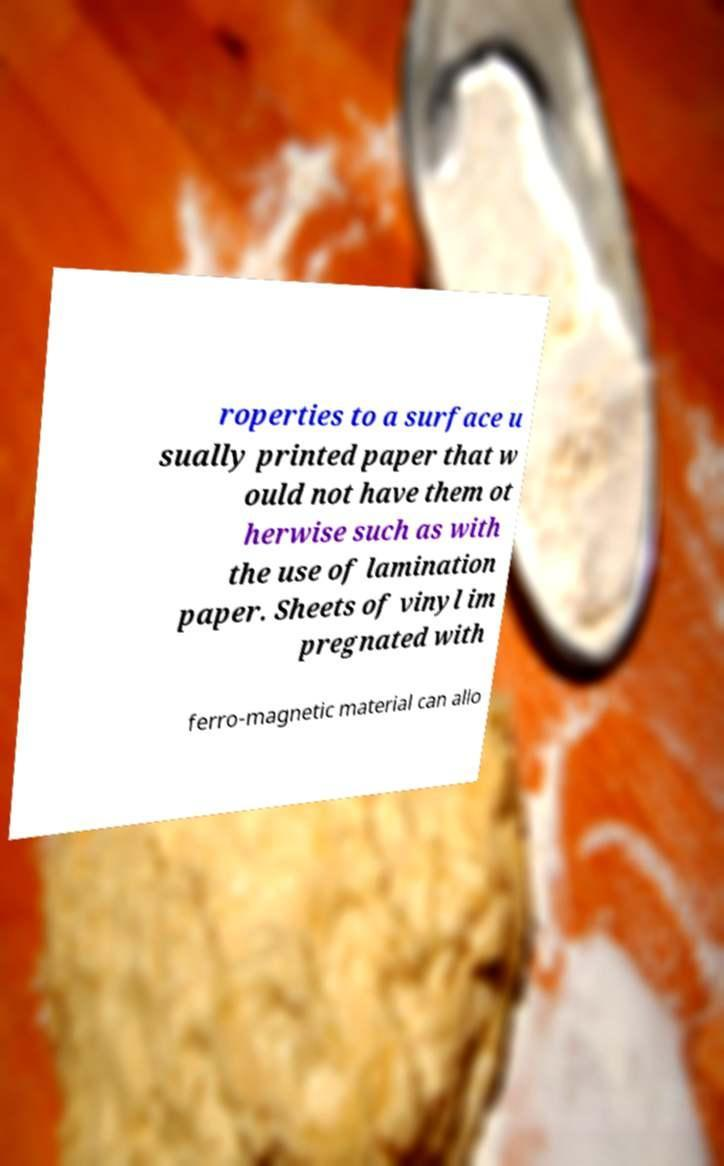There's text embedded in this image that I need extracted. Can you transcribe it verbatim? roperties to a surface u sually printed paper that w ould not have them ot herwise such as with the use of lamination paper. Sheets of vinyl im pregnated with ferro-magnetic material can allo 